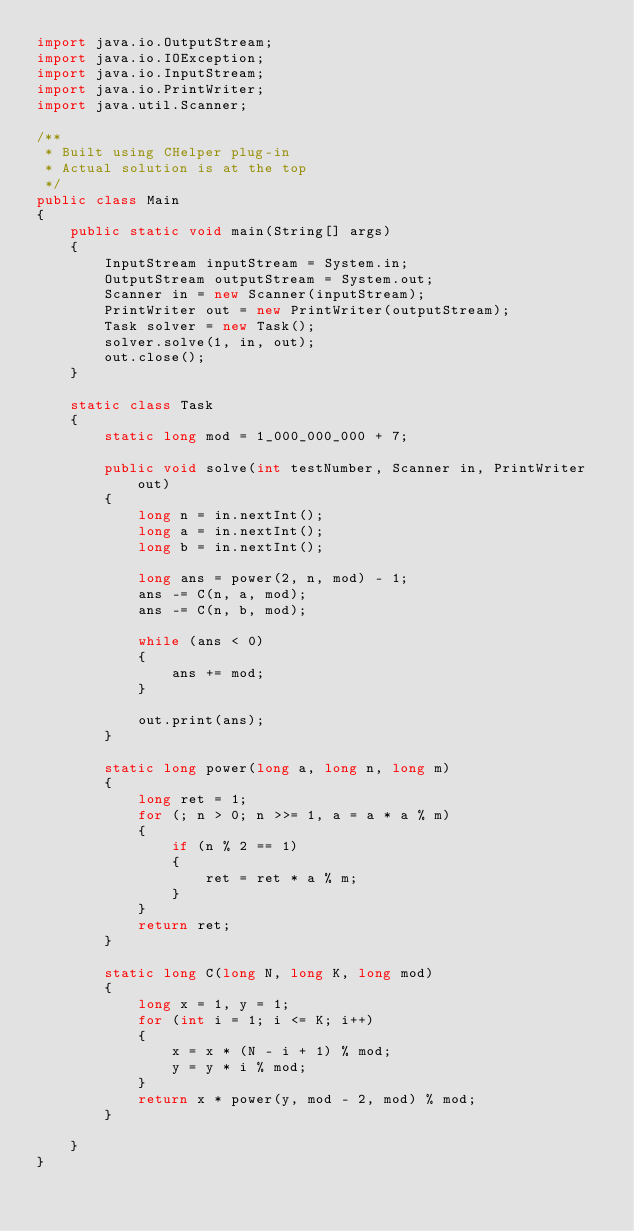<code> <loc_0><loc_0><loc_500><loc_500><_Java_>import java.io.OutputStream;
import java.io.IOException;
import java.io.InputStream;
import java.io.PrintWriter;
import java.util.Scanner;

/**
 * Built using CHelper plug-in
 * Actual solution is at the top
 */
public class Main
{
    public static void main(String[] args)
    {
        InputStream inputStream = System.in;
        OutputStream outputStream = System.out;
        Scanner in = new Scanner(inputStream);
        PrintWriter out = new PrintWriter(outputStream);
        Task solver = new Task();
        solver.solve(1, in, out);
        out.close();
    }

    static class Task
    {
        static long mod = 1_000_000_000 + 7;

        public void solve(int testNumber, Scanner in, PrintWriter out)
        {
            long n = in.nextInt();
            long a = in.nextInt();
            long b = in.nextInt();

            long ans = power(2, n, mod) - 1;
            ans -= C(n, a, mod);
            ans -= C(n, b, mod);

            while (ans < 0)
            {
                ans += mod;
            }

            out.print(ans);
        }

        static long power(long a, long n, long m)
        {
            long ret = 1;
            for (; n > 0; n >>= 1, a = a * a % m)
            {
                if (n % 2 == 1)
                {
                    ret = ret * a % m;
                }
            }
            return ret;
        }

        static long C(long N, long K, long mod)
        {
            long x = 1, y = 1;
            for (int i = 1; i <= K; i++)
            {
                x = x * (N - i + 1) % mod;
                y = y * i % mod;
            }
            return x * power(y, mod - 2, mod) % mod;
        }

    }
}

</code> 